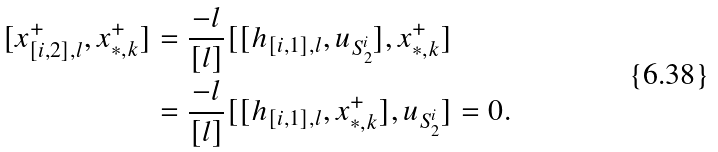Convert formula to latex. <formula><loc_0><loc_0><loc_500><loc_500>[ x ^ { + } _ { [ i , 2 ] , l } , x ^ { + } _ { * , k } ] & = \frac { - l } { [ l ] } [ [ h _ { [ i , 1 ] , l } , u _ { S ^ { i } _ { 2 } } ] , x ^ { + } _ { * , k } ] \\ & = \frac { - l } { [ l ] } [ [ h _ { [ i , 1 ] , l } , x ^ { + } _ { * , k } ] , u _ { S ^ { i } _ { 2 } } ] = 0 .</formula> 